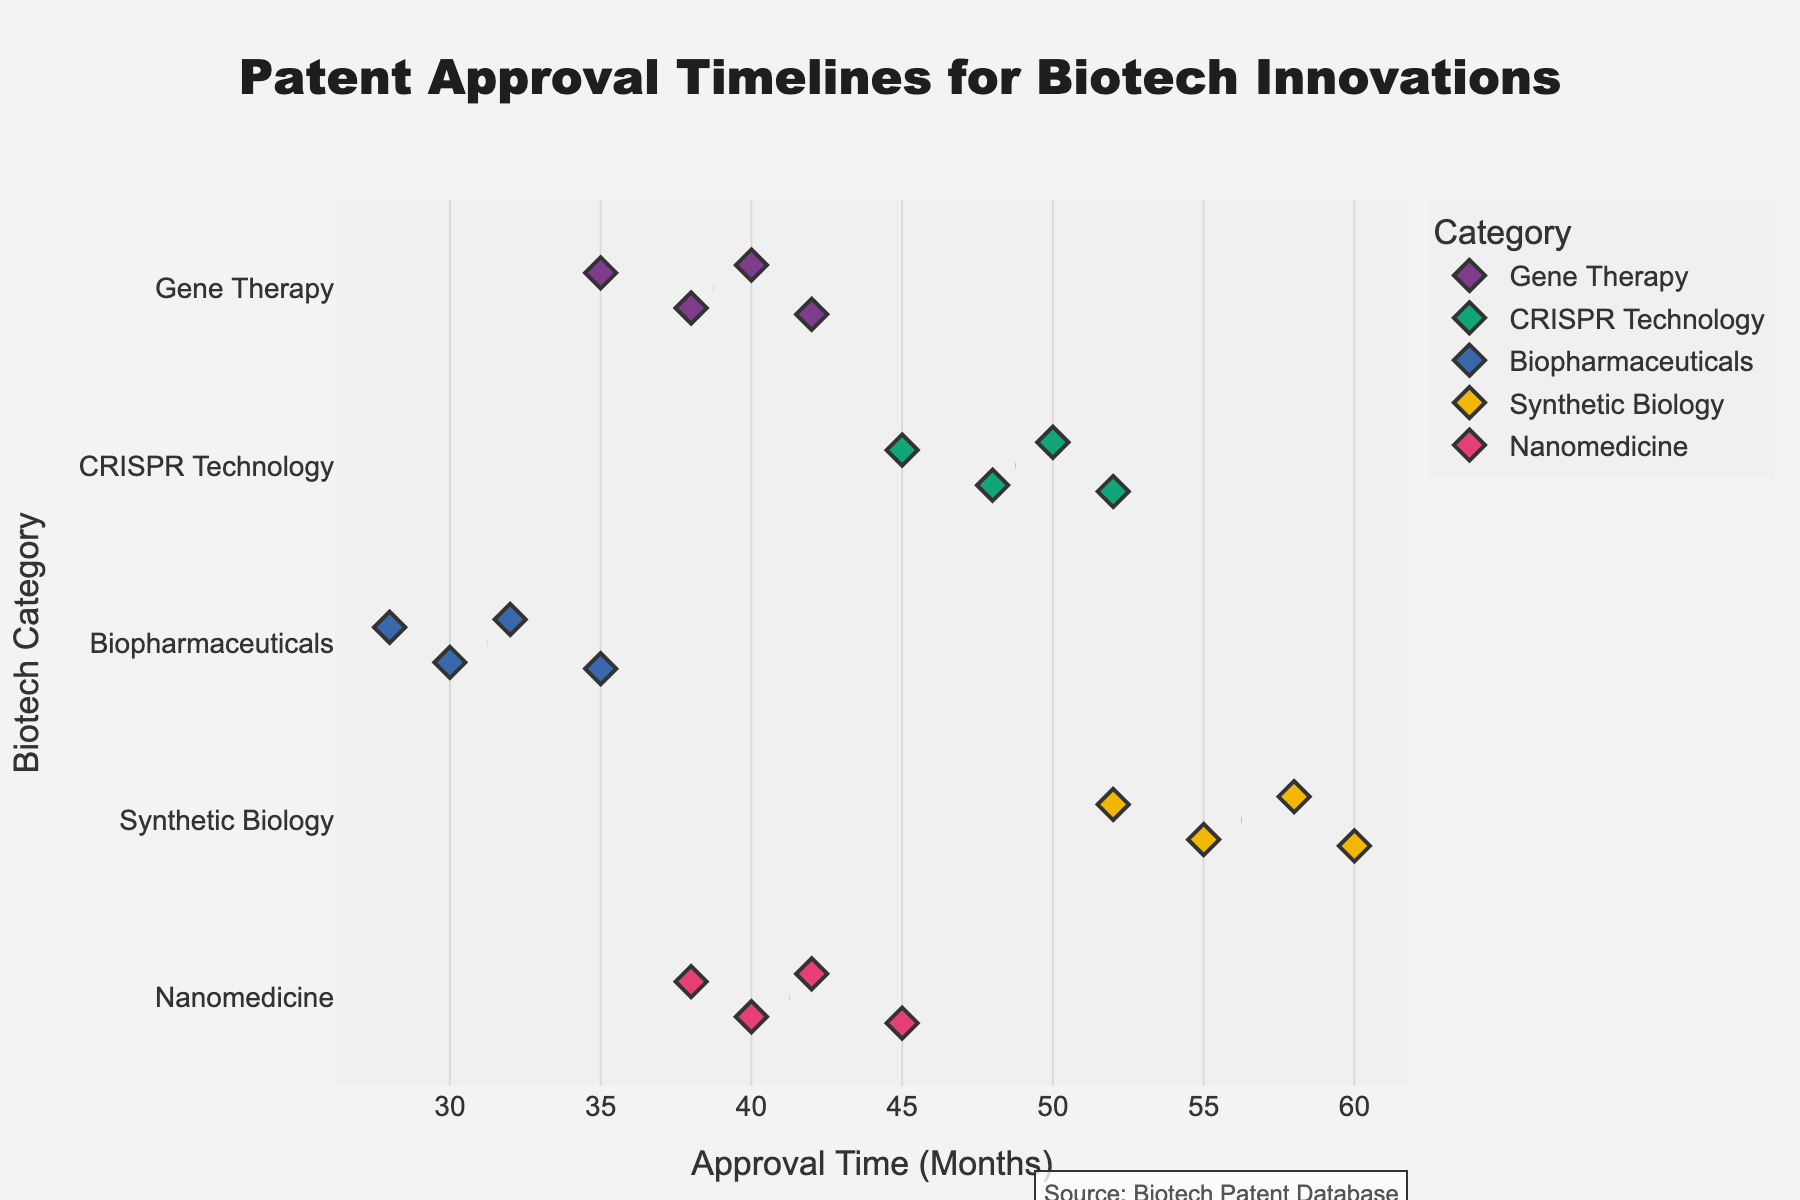What's the title of the figure? The title of the figure is displayed prominently at the top.
Answer: "Patent Approval Timelines for Biotech Innovations" Which biotech category has the longest average patent approval time? Look at the strip plot and find the average (mean) lines marked in red. The Synthetic Biology category has the mean located farthest to the right compared to other categories.
Answer: Synthetic Biology How many data points are shown for the Gene Therapy category? Count the number of diamond-shaped markers in the Gene Therapy category row in the strip plot.
Answer: 4 Which category has the shortest single patent approval time? Identify the leftmost diamond marker on the strip plot. The Biopharmaceuticals category has the diamond at 28 months.
Answer: Biopharmaceuticals What’s the range of patent approval times for CRISPR Technology? Find the minimum and maximum values for CRISPR Technology by identifying the leftmost and rightmost diamond markers for this category. The minimum is 45 and the maximum is 52 months. The range is 52 - 45 = 7 months.
Answer: 7 months Compare the mean patent approval time of Gene Therapy and Nanomedicine categories. Which one is lower? Look at the red dashed lines indicating the mean for both categories. The Gene Therapy mean line is to the left of the Nanomedicine mean line, indicating a lower mean patent approval time.
Answer: Gene Therapy Which category shows the highest variation in patent approval times? Observe the spread of diamond markers along the x-axis. The Synthetic Biology category has the diamond markers that are the most spread out.
Answer: Synthetic Biology Are there any categories with overlapping approval time ranges? If yes, which ones? Check if any rows have diamond markers that fall within the same range on the x-axis. Both Gene Therapy and Nanomedicine have approval times in the range of 38-45 months, indicating overlap.
Answer: Gene Therapy and Nanomedicine 